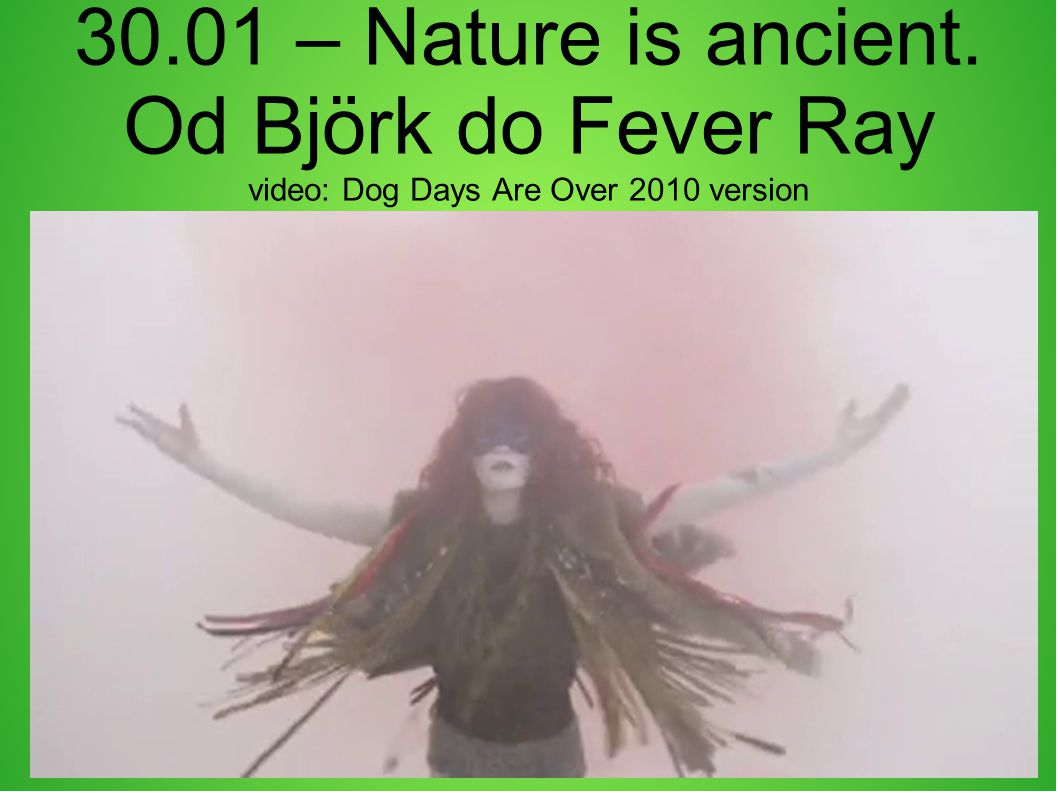Can we infer anything about the themes of the video from this image? Yes, we can infer several potential themes from this image. The dramatic costume, the outstretched arms, and the presence of fog suggest themes of transformation, liberation, or transcendence. The title 'Dog Days Are Over' also implies a narrative of overcoming hardship or renewal. This image may represent a climactic moment in the video that captures the essence of emerging from a challenging period into a new beginning. 